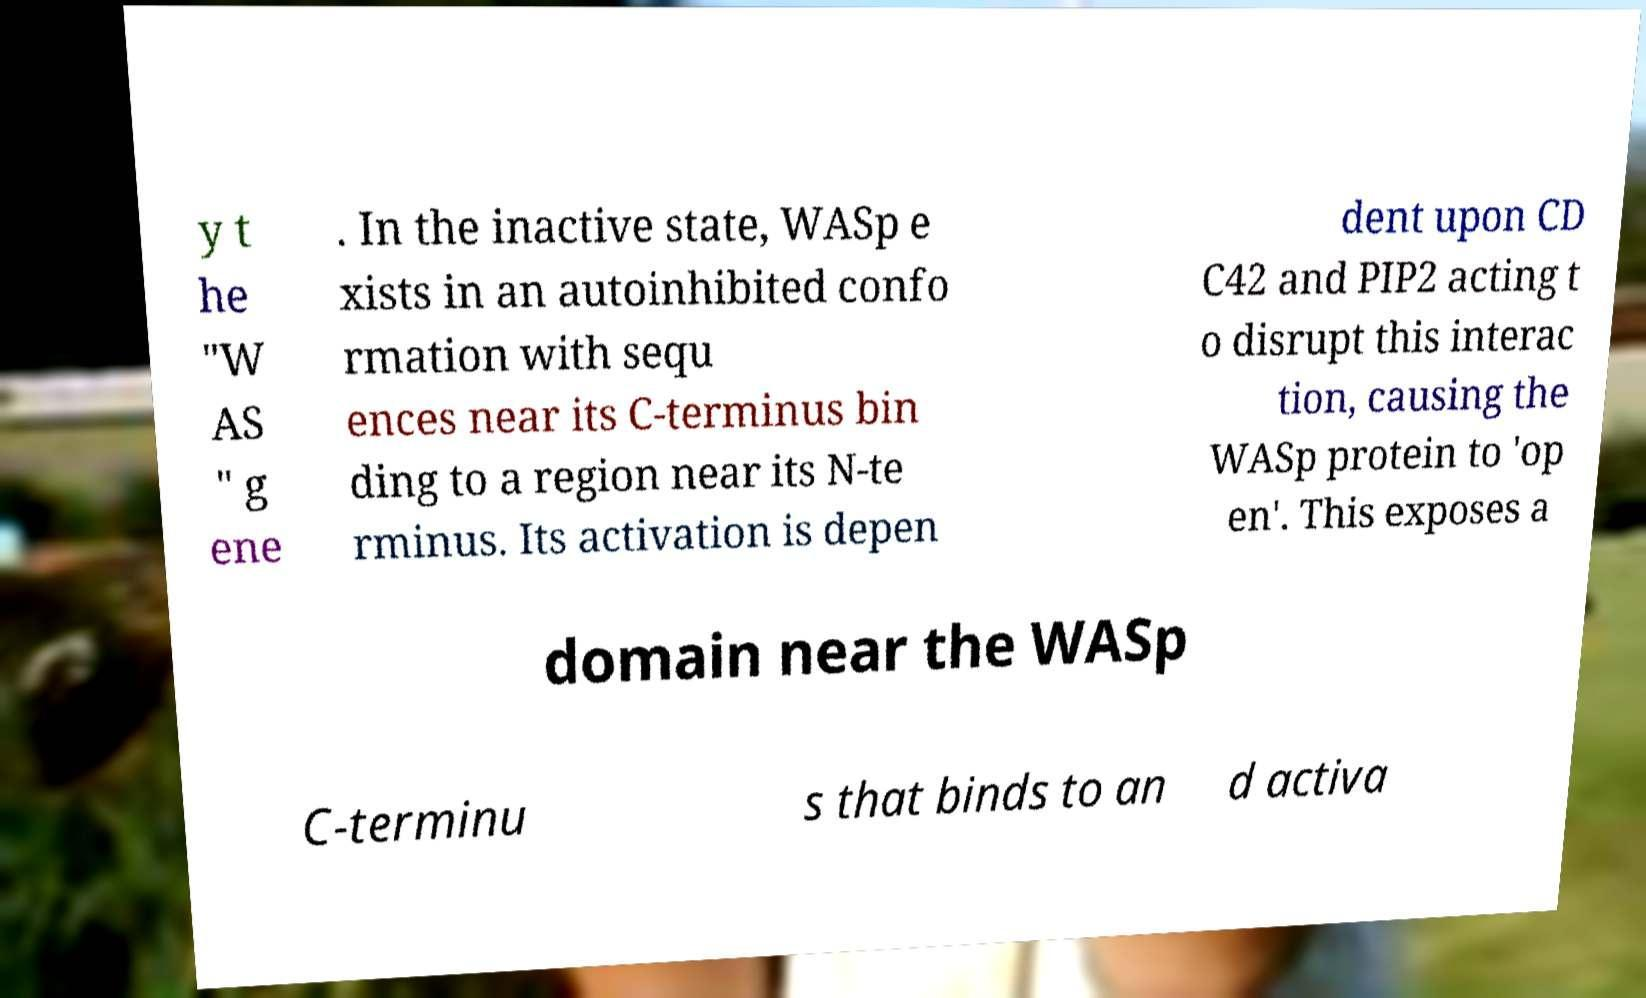Please read and relay the text visible in this image. What does it say? y t he "W AS " g ene . In the inactive state, WASp e xists in an autoinhibited confo rmation with sequ ences near its C-terminus bin ding to a region near its N-te rminus. Its activation is depen dent upon CD C42 and PIP2 acting t o disrupt this interac tion, causing the WASp protein to 'op en'. This exposes a domain near the WASp C-terminu s that binds to an d activa 